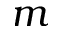<formula> <loc_0><loc_0><loc_500><loc_500>m</formula> 